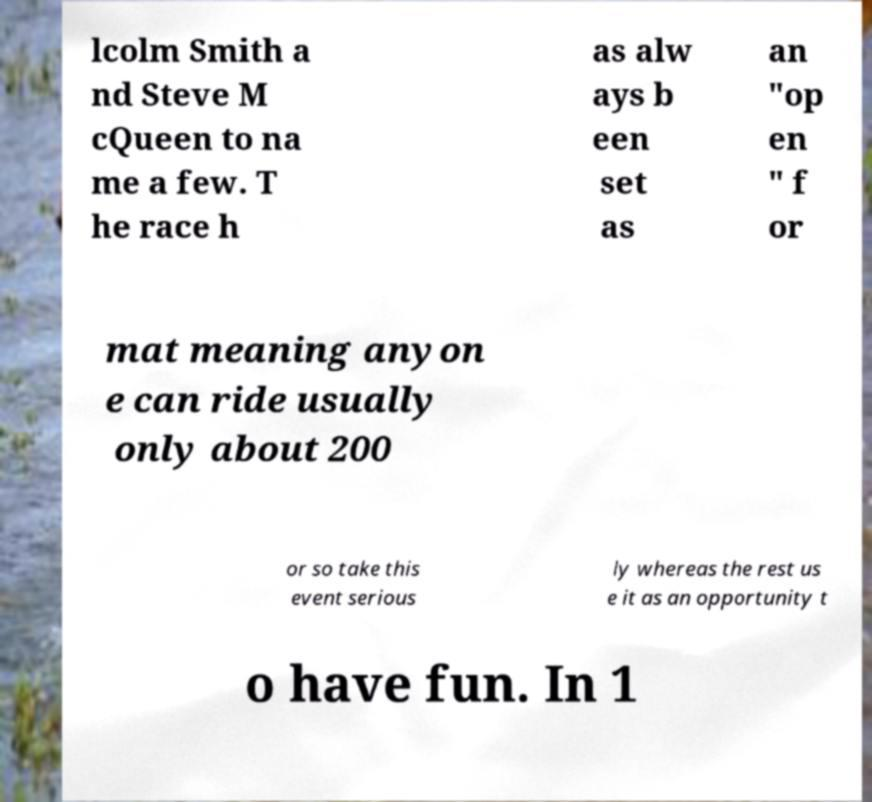Please read and relay the text visible in this image. What does it say? lcolm Smith a nd Steve M cQueen to na me a few. T he race h as alw ays b een set as an "op en " f or mat meaning anyon e can ride usually only about 200 or so take this event serious ly whereas the rest us e it as an opportunity t o have fun. In 1 